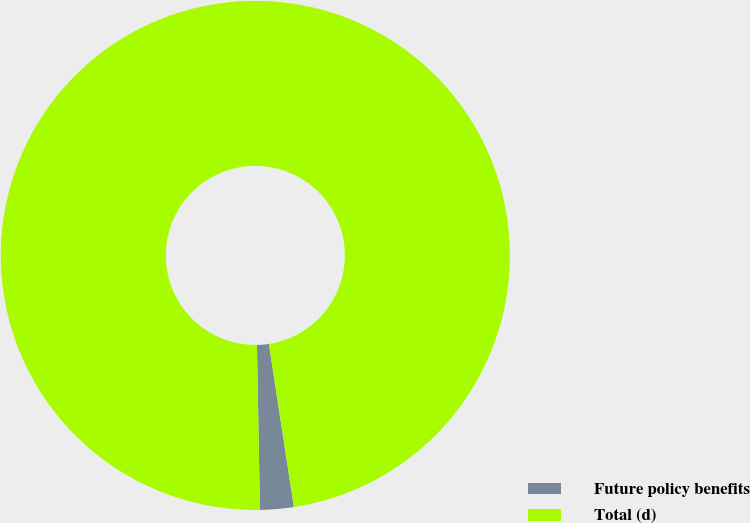<chart> <loc_0><loc_0><loc_500><loc_500><pie_chart><fcel>Future policy benefits<fcel>Total (d)<nl><fcel>2.13%<fcel>97.87%<nl></chart> 